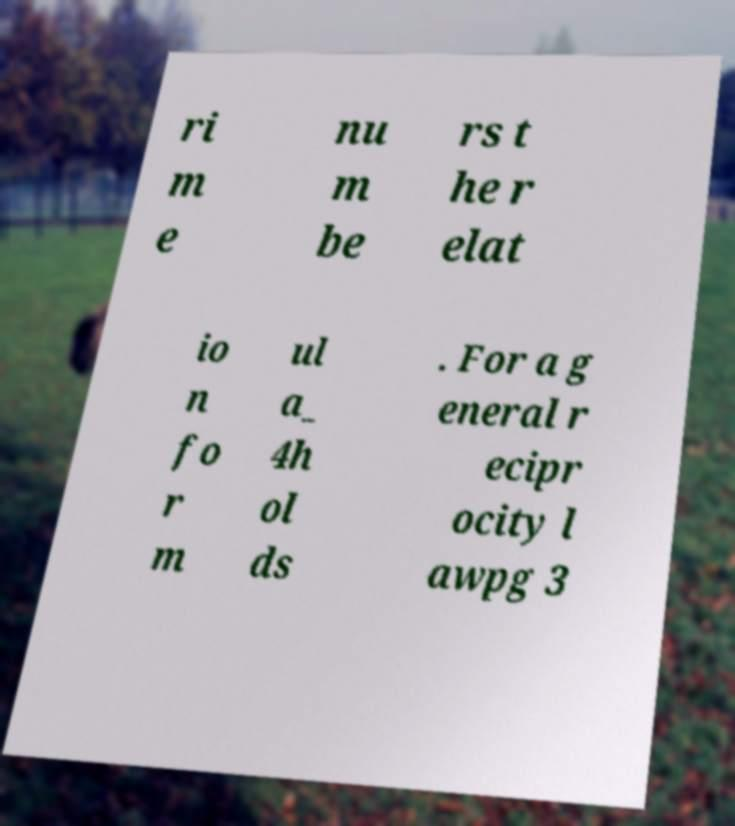Could you assist in decoding the text presented in this image and type it out clearly? ri m e nu m be rs t he r elat io n fo r m ul a_ 4h ol ds . For a g eneral r ecipr ocity l awpg 3 